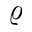Convert formula to latex. <formula><loc_0><loc_0><loc_500><loc_500>\varrho</formula> 